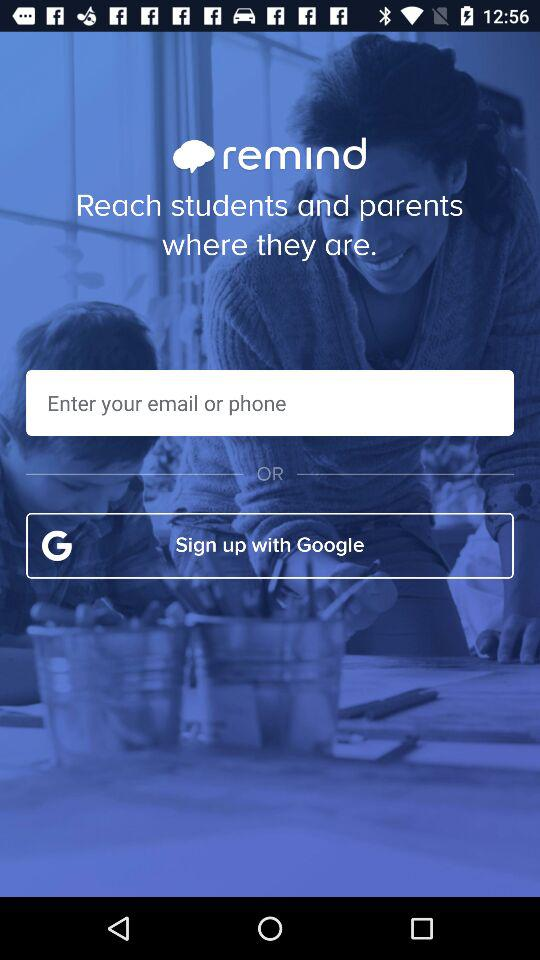What is the app title? The app title is "remind". 